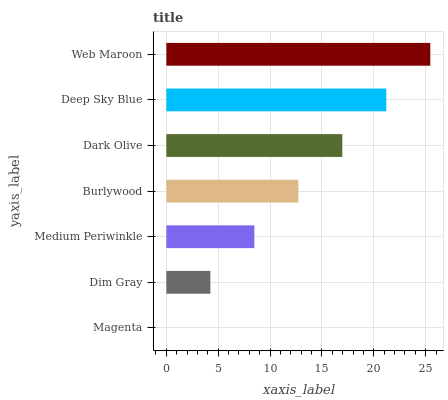Is Magenta the minimum?
Answer yes or no. Yes. Is Web Maroon the maximum?
Answer yes or no. Yes. Is Dim Gray the minimum?
Answer yes or no. No. Is Dim Gray the maximum?
Answer yes or no. No. Is Dim Gray greater than Magenta?
Answer yes or no. Yes. Is Magenta less than Dim Gray?
Answer yes or no. Yes. Is Magenta greater than Dim Gray?
Answer yes or no. No. Is Dim Gray less than Magenta?
Answer yes or no. No. Is Burlywood the high median?
Answer yes or no. Yes. Is Burlywood the low median?
Answer yes or no. Yes. Is Web Maroon the high median?
Answer yes or no. No. Is Dim Gray the low median?
Answer yes or no. No. 